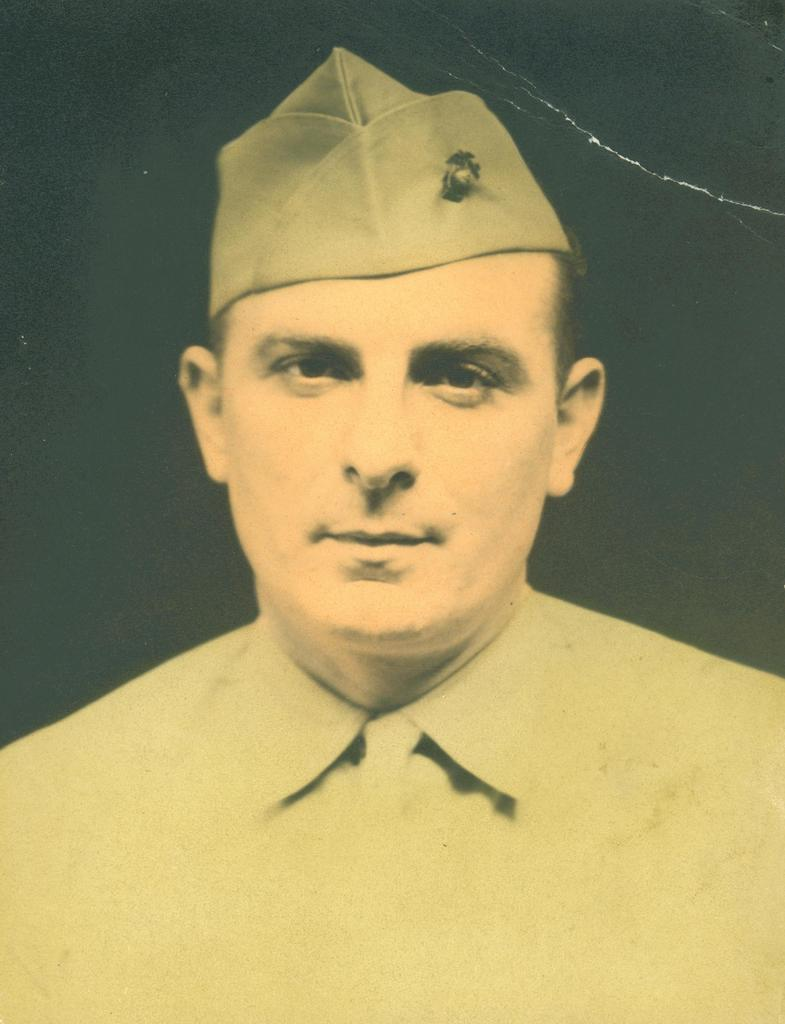What is the main subject of the image? There is a photograph in the image. What is shown in the photograph? The photograph depicts a person. How many fingers does the person in the photograph have? The image does not show the person's fingers, so it cannot be determined from the image. 